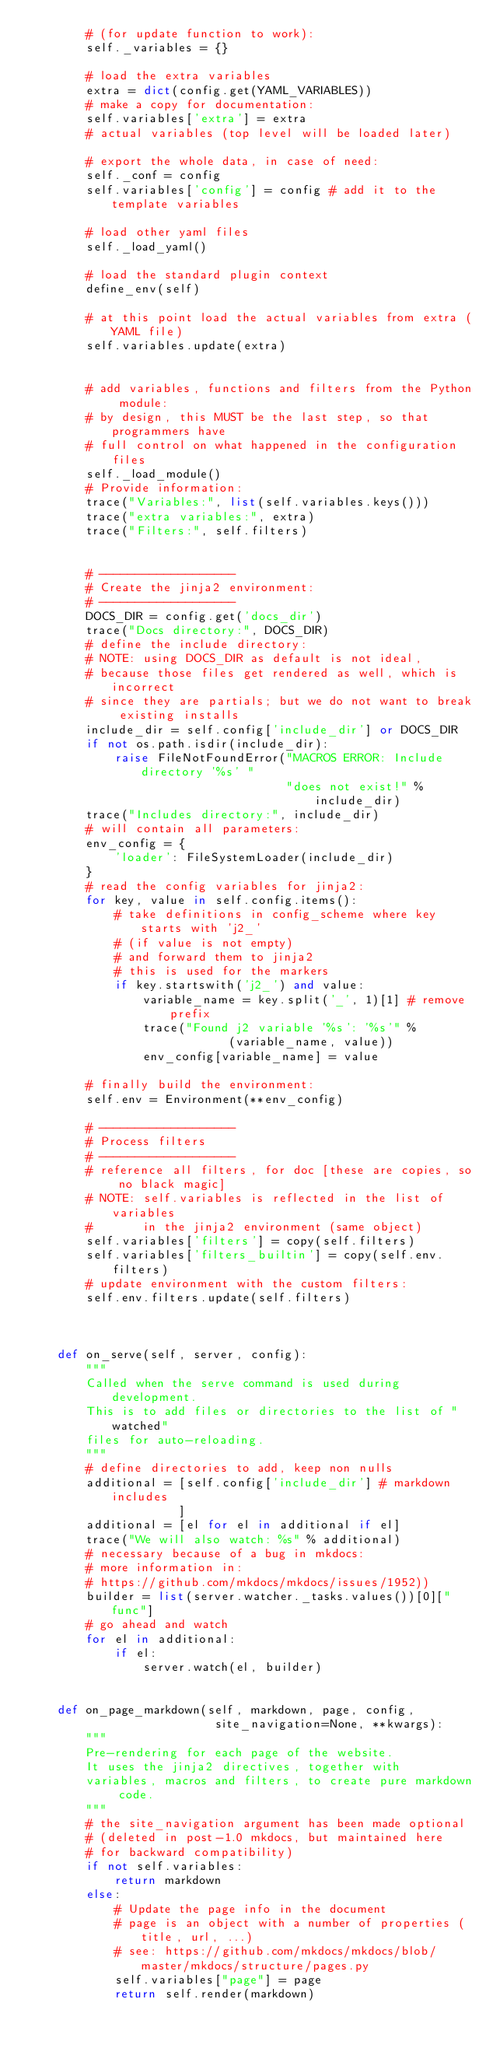Convert code to text. <code><loc_0><loc_0><loc_500><loc_500><_Python_>        # (for update function to work):
        self._variables = {}

        # load the extra variables
        extra = dict(config.get(YAML_VARIABLES))
        # make a copy for documentation:
        self.variables['extra'] = extra 
        # actual variables (top level will be loaded later)

        # export the whole data, in case of need:
        self._conf = config
        self.variables['config'] = config # add it to the template variables

        # load other yaml files
        self._load_yaml()

        # load the standard plugin context
        define_env(self)

        # at this point load the actual variables from extra (YAML file)
        self.variables.update(extra)
        

        # add variables, functions and filters from the Python module:
        # by design, this MUST be the last step, so that programmers have
        # full control on what happened in the configuration files
        self._load_module()
        # Provide information:
        trace("Variables:", list(self.variables.keys()))
        trace("extra variables:", extra)
        trace("Filters:", self.filters)
        

        # -------------------
        # Create the jinja2 environment:
        # -------------------
        DOCS_DIR = config.get('docs_dir')
        trace("Docs directory:", DOCS_DIR)
        # define the include directory:
        # NOTE: using DOCS_DIR as default is not ideal,
        # because those files get rendered as well, which is incorrect
        # since they are partials; but we do not want to break existing installs
        include_dir = self.config['include_dir'] or DOCS_DIR
        if not os.path.isdir(include_dir):
            raise FileNotFoundError("MACROS ERROR: Include directory '%s' "
                                    "does not exist!" %
                                        include_dir)
        trace("Includes directory:", include_dir)
        # will contain all parameters:
        env_config = {
            'loader': FileSystemLoader(include_dir)
        }
        # read the config variables for jinja2:
        for key, value in self.config.items():
            # take definitions in config_scheme where key starts with 'j2_'
            # (if value is not empty) 
            # and forward them to jinja2
            # this is used for the markers
            if key.startswith('j2_') and value:
                variable_name = key.split('_', 1)[1] # remove prefix
                trace("Found j2 variable '%s': '%s'" %
                            (variable_name, value))
                env_config[variable_name] = value
        
        # finally build the environment:
        self.env = Environment(**env_config)

        # -------------------
        # Process filters
        # -------------------
        # reference all filters, for doc [these are copies, so no black magic]
        # NOTE: self.variables is reflected in the list of variables
        #       in the jinja2 environment (same object)
        self.variables['filters'] = copy(self.filters) 
        self.variables['filters_builtin'] = copy(self.env.filters) 
        # update environment with the custom filters:
        self.env.filters.update(self.filters)

        
        
    def on_serve(self, server, config):
        """
        Called when the serve command is used during development.
        This is to add files or directories to the list of "watched" 
        files for auto-reloading.
        """
        # define directories to add, keep non nulls
        additional = [self.config['include_dir'] # markdown includes
                     ]
        additional = [el for el in additional if el]
        trace("We will also watch: %s" % additional)
        # necessary because of a bug in mkdocs:
        # more information in:
        # https://github.com/mkdocs/mkdocs/issues/1952))
        builder = list(server.watcher._tasks.values())[0]["func"]
        # go ahead and watch
        for el in additional:
            if el:
                server.watch(el, builder)        


    def on_page_markdown(self, markdown, page, config,
                          site_navigation=None, **kwargs):
        """
        Pre-rendering for each page of the website.
        It uses the jinja2 directives, together with
        variables, macros and filters, to create pure markdown code.
        """
        # the site_navigation argument has been made optional
        # (deleted in post-1.0 mkdocs, but maintained here
        # for backward compatibility)
        if not self.variables:
            return markdown
        else:
            # Update the page info in the document
            # page is an object with a number of properties (title, url, ...)
            # see: https://github.com/mkdocs/mkdocs/blob/master/mkdocs/structure/pages.py
            self.variables["page"] = page
            return self.render(markdown)
</code> 